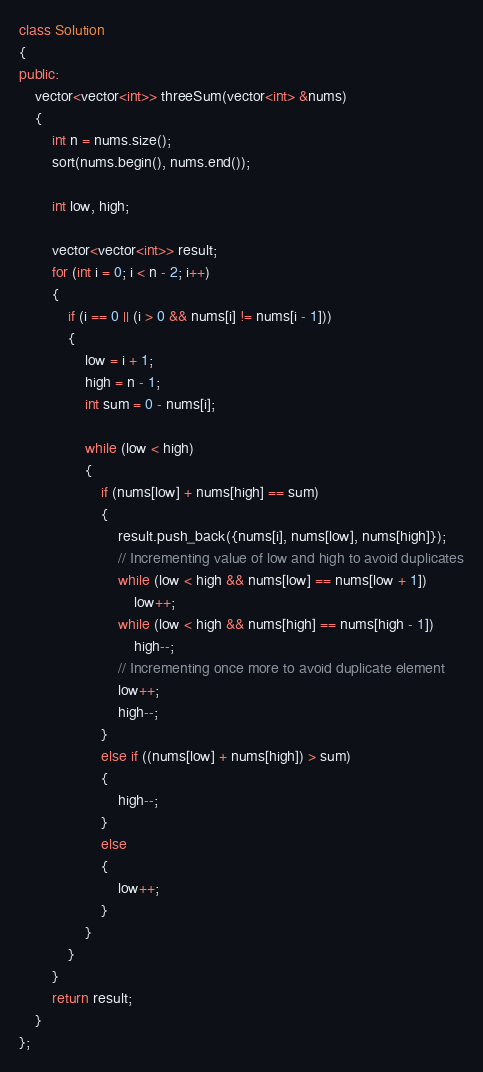Convert code to text. <code><loc_0><loc_0><loc_500><loc_500><_C++_>class Solution
{
public:
    vector<vector<int>> threeSum(vector<int> &nums)
    {
        int n = nums.size();
        sort(nums.begin(), nums.end());

        int low, high;

        vector<vector<int>> result;
        for (int i = 0; i < n - 2; i++)
        {
            if (i == 0 || (i > 0 && nums[i] != nums[i - 1]))
            {
                low = i + 1;
                high = n - 1;
                int sum = 0 - nums[i];

                while (low < high)
                {
                    if (nums[low] + nums[high] == sum)
                    {
                        result.push_back({nums[i], nums[low], nums[high]});
                        // Incrementing value of low and high to avoid duplicates
                        while (low < high && nums[low] == nums[low + 1])
                            low++;
                        while (low < high && nums[high] == nums[high - 1])
                            high--;
                        // Incrementing once more to avoid duplicate element
                        low++;
                        high--;
                    }
                    else if ((nums[low] + nums[high]) > sum)
                    {
                        high--;
                    }
                    else
                    {
                        low++;
                    }
                }
            }
        }
        return result;
    }
};</code> 